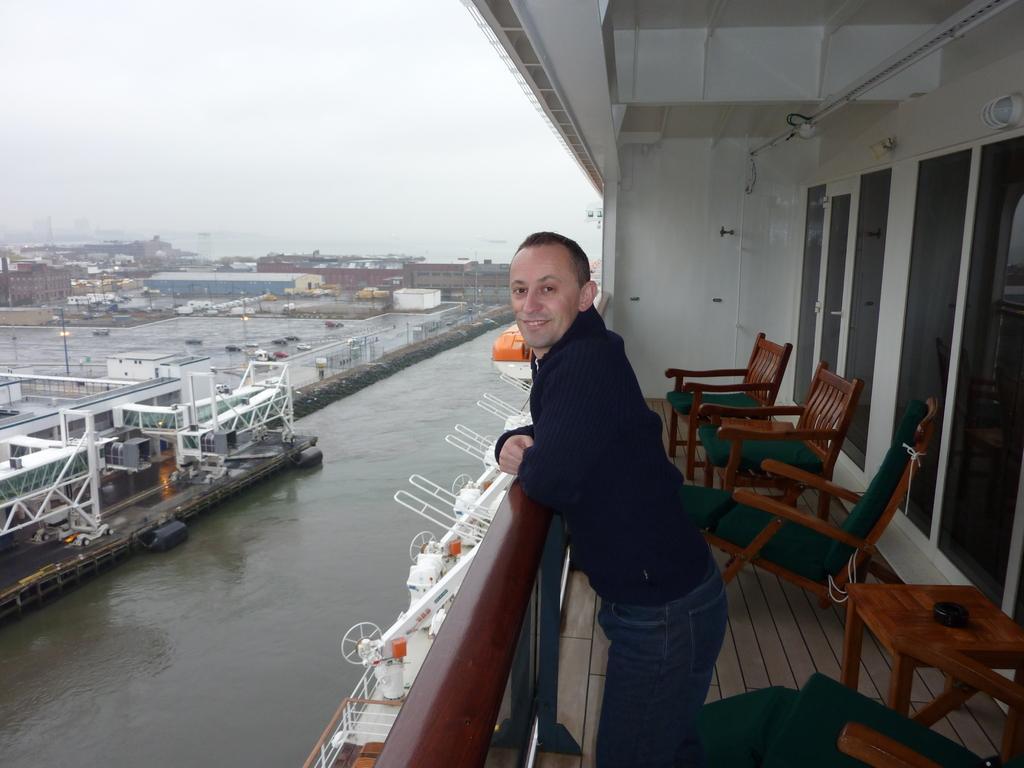Please provide a concise description of this image. In this picture we can see a man who is standing on the floor. These are the chairs and there is a table. Here we can see a door. This is water. On the background there is a sky and this is building. 